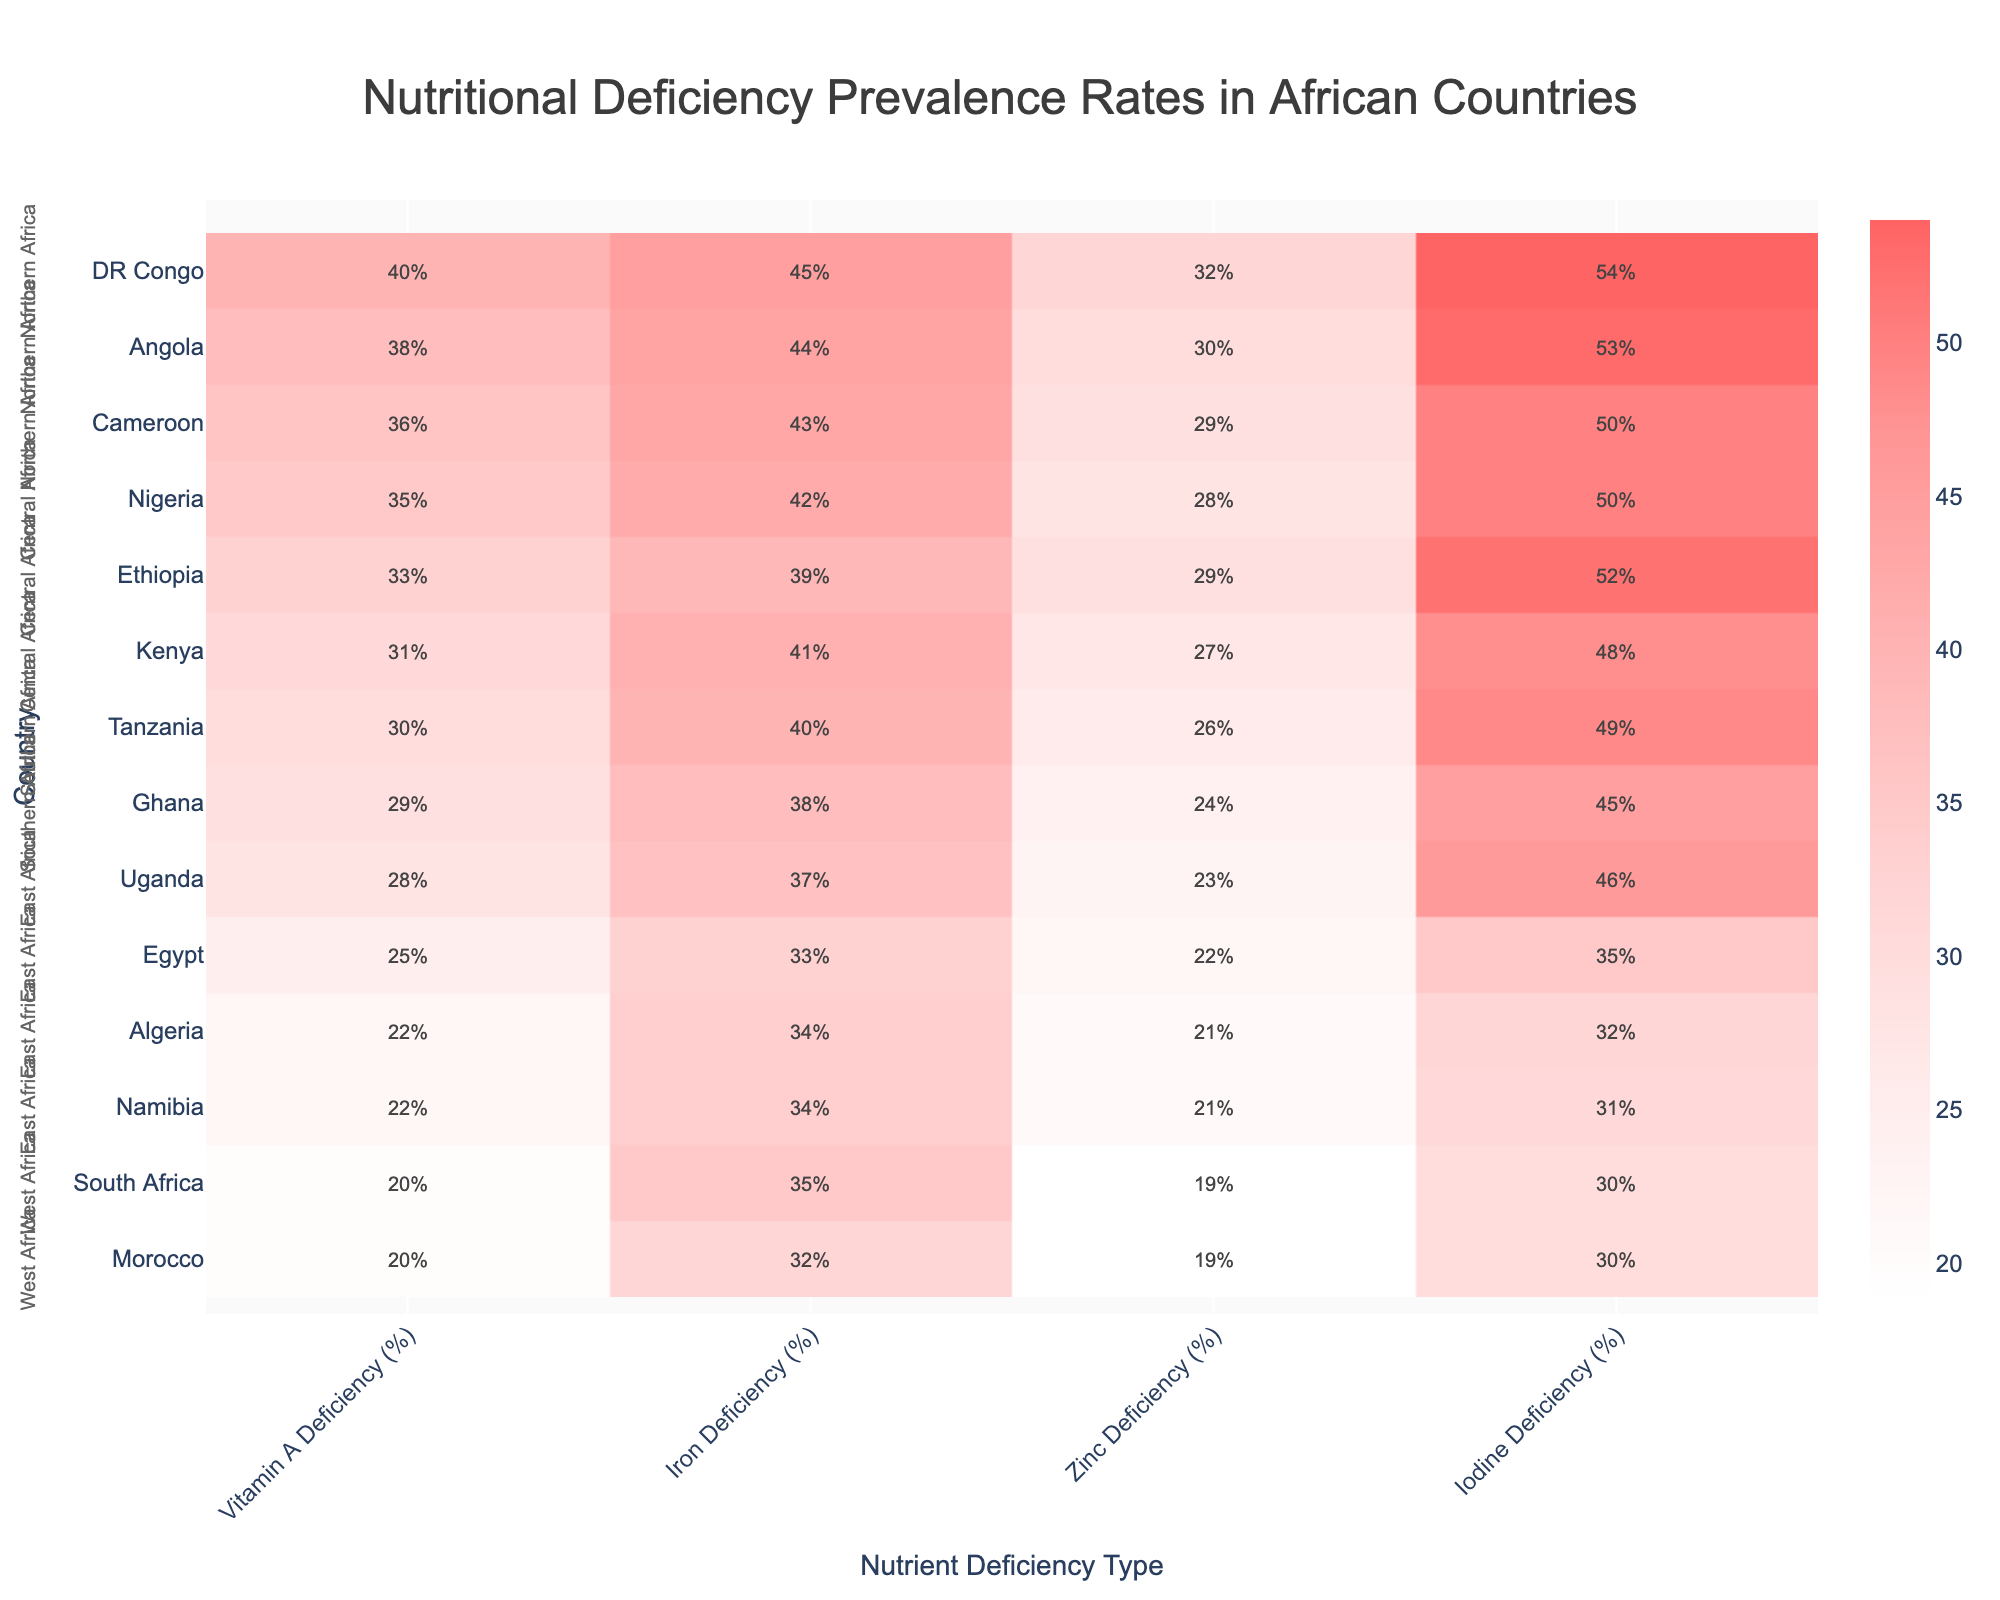What's the title of the heatmap? The title is usually placed at the top of the figure. Here, it says "Nutritional Deficiency Prevalence Rates in African Countries".
Answer: Nutritional Deficiency Prevalence Rates in African Countries Which country in the East Africa region has the highest vitamin A deficiency rate? Identify the countries in East Africa (Kenya, Tanzania, Ethiopia, Uganda) and compare their Vitamin A Deficiency (%). Ethiopia has the highest at 33%.
Answer: Ethiopia Which region has the lowest iron deficiency rate and what is the corresponding value? Scan for the region with the minimum iron deficiency value across countries. Northern Africa shows the lowest rates, and Egypt has the lowest at 33%.
Answer: Northern Africa, 33% How many countries in the West Africa region are displayed on the figure? Look at the countries listed under 'West Africa' (Nigeria, Ghana). Count them.
Answer: 2 Which nutrient deficiency type is most prevalent in DR Congo and what is its percentage? Locate DR Congo on the y-axis and check the deficiency percentages across nutrient types. Iodine Deficiency is the highest at 54%.
Answer: Iodine Deficiency, 54% What is the average Zinc deficiency rate for countries in Southern Africa? Identify the countries in Southern Africa (South Africa, Namibia) and their Zinc Deficiency rates (19%, 21%). Calculate the mean: (19 + 21) / 2 = 20%.
Answer: 20% Which country has the highest overall nutritional deficiency rate and for which nutrient? Scroll through each country and determine the highest percentage deficiency. DR Congo has the highest overall rate with Iodine Deficiency at 54%.
Answer: DR Congo, Iodine Deficiency Compare the iron deficiency rates between Kenya and Tanzania. Which country has a higher rate and by how much? Check the Iron Deficiency rates for Kenya (41%) and Tanzania (40%). Kenya’s rate is 1% higher than Tanzania’s.
Answer: Kenya, by 1% What is the range of iodine deficiency rates in Northern African countries? Identify Iodine Deficiency rates for Egypt (35%), Morocco (30%), and Algeria (32%), compute the range: Maximum - Minimum, which is 35% - 30% = 5%.
Answer: 5% Which nutrient deficiency is more common in Ghana compared to South Africa? For Ghana: Vitamin A (29%), Iron (38%), Zinc (24%), Iodine (45%). For South Africa: Vitamin A (20%), Iron (35%), Zinc (19%), Iodine (30%). Compare values, and Ghana has higher rates in all.
Answer: All nutrients 